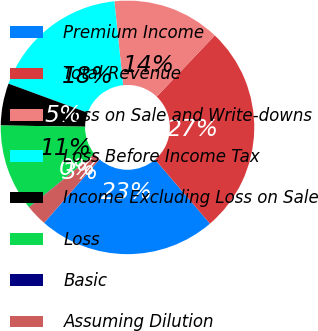Convert chart. <chart><loc_0><loc_0><loc_500><loc_500><pie_chart><fcel>Premium Income<fcel>Total Revenue<fcel>Loss on Sale and Write-downs<fcel>Loss Before Income Tax<fcel>Income Excluding Loss on Sale<fcel>Loss<fcel>Basic<fcel>Assuming Dilution<nl><fcel>22.69%<fcel>26.64%<fcel>13.74%<fcel>17.75%<fcel>5.36%<fcel>11.08%<fcel>0.04%<fcel>2.7%<nl></chart> 